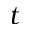Convert formula to latex. <formula><loc_0><loc_0><loc_500><loc_500>t</formula> 